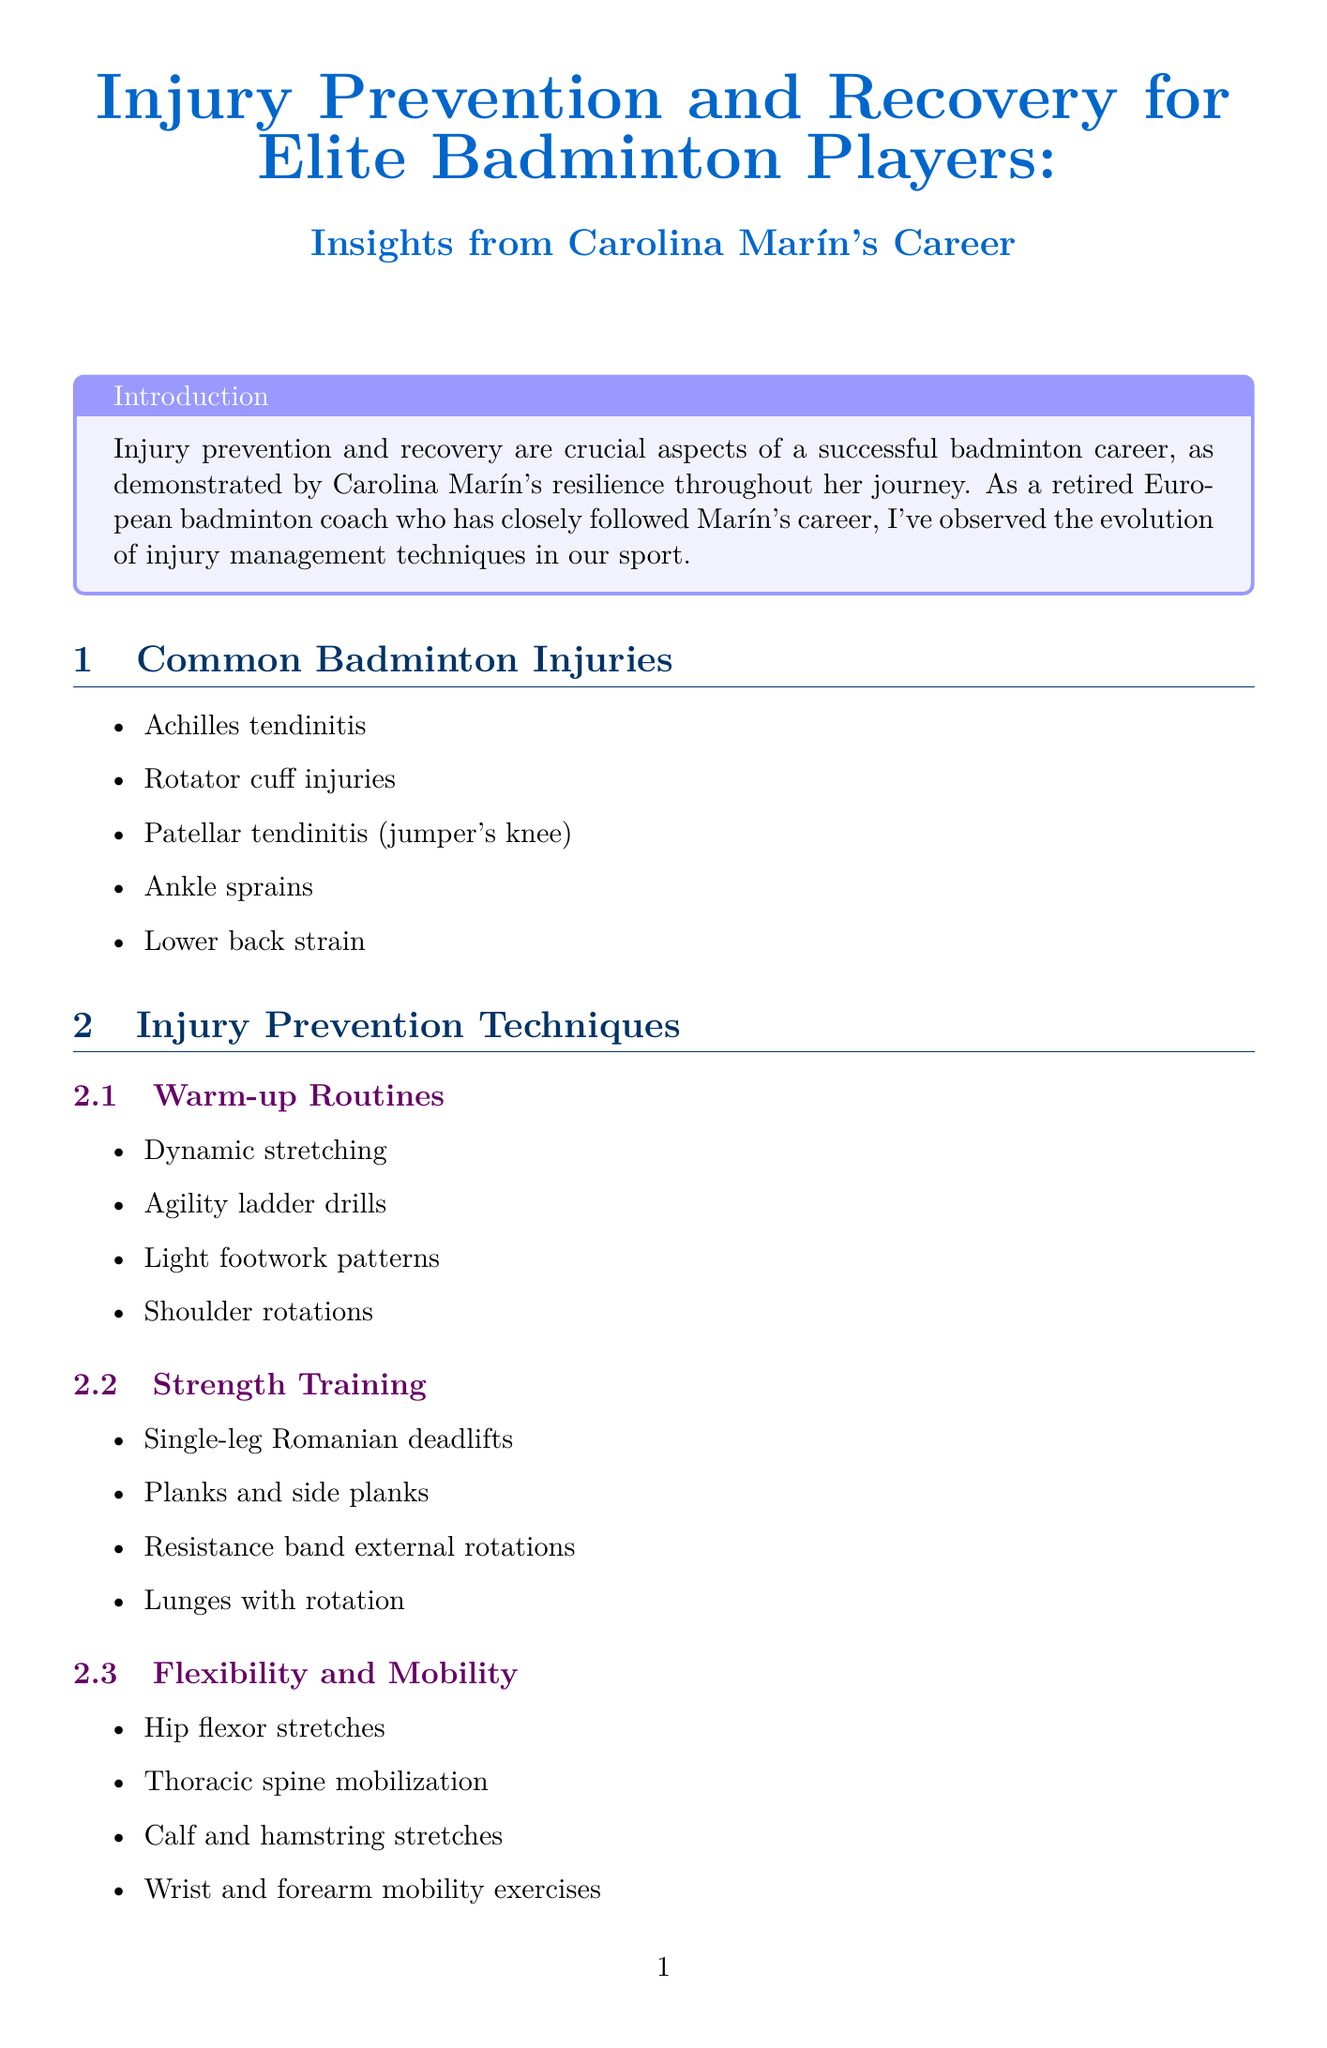What are common badminton injuries? Common badminton injuries are listed in the document and include Achilles tendinitis, rotator cuff injuries, patellar tendinitis, ankle sprains, and lower back strain.
Answer: Achilles tendinitis, rotator cuff injuries, patellar tendinitis, ankle sprains, lower back strain What recovery technique involves self-massage? The document lists recovery techniques, one of which is foam rolling and self-massage.
Answer: Foam rolling and self-massage What date did Carolina Marín sustain her ACL injury? The document specifies the date of Carolina Marín's ACL injury during the Indonesia Masters final as January 2019.
Answer: January 2019 How long after her ACL surgery did Marín return to on-court training? Based on the timeline, Carolina Marín returned to on-court training in August 2019, which is six months after her surgery in February 2019.
Answer: Six months What type of exercise aids in ankle stability? The document provides a rehabilitation exercise called "Single-leg balance" that targets ankle stability and proprioception.
Answer: Single-leg balance What are the key recovery elements Marín implemented post-injury? The document highlights four key recovery elements that Marín used: personalized physiotherapy program, mental resilience training, gradual return to play protocol, and continued injury prevention exercises.
Answer: Personalized physiotherapy program, mental resilience training, gradual return to play protocol, continued injury prevention exercises Which technology is used for movement analysis? The document mentions the Hawkeye system as a tool for movement analysis in injury prevention.
Answer: Hawkeye system What nutritional element is recommended for tendon health? The document states that Vitamin C and collagen are recommended for tendon health during recovery and injury prevention.
Answer: Vitamin C and collagen 